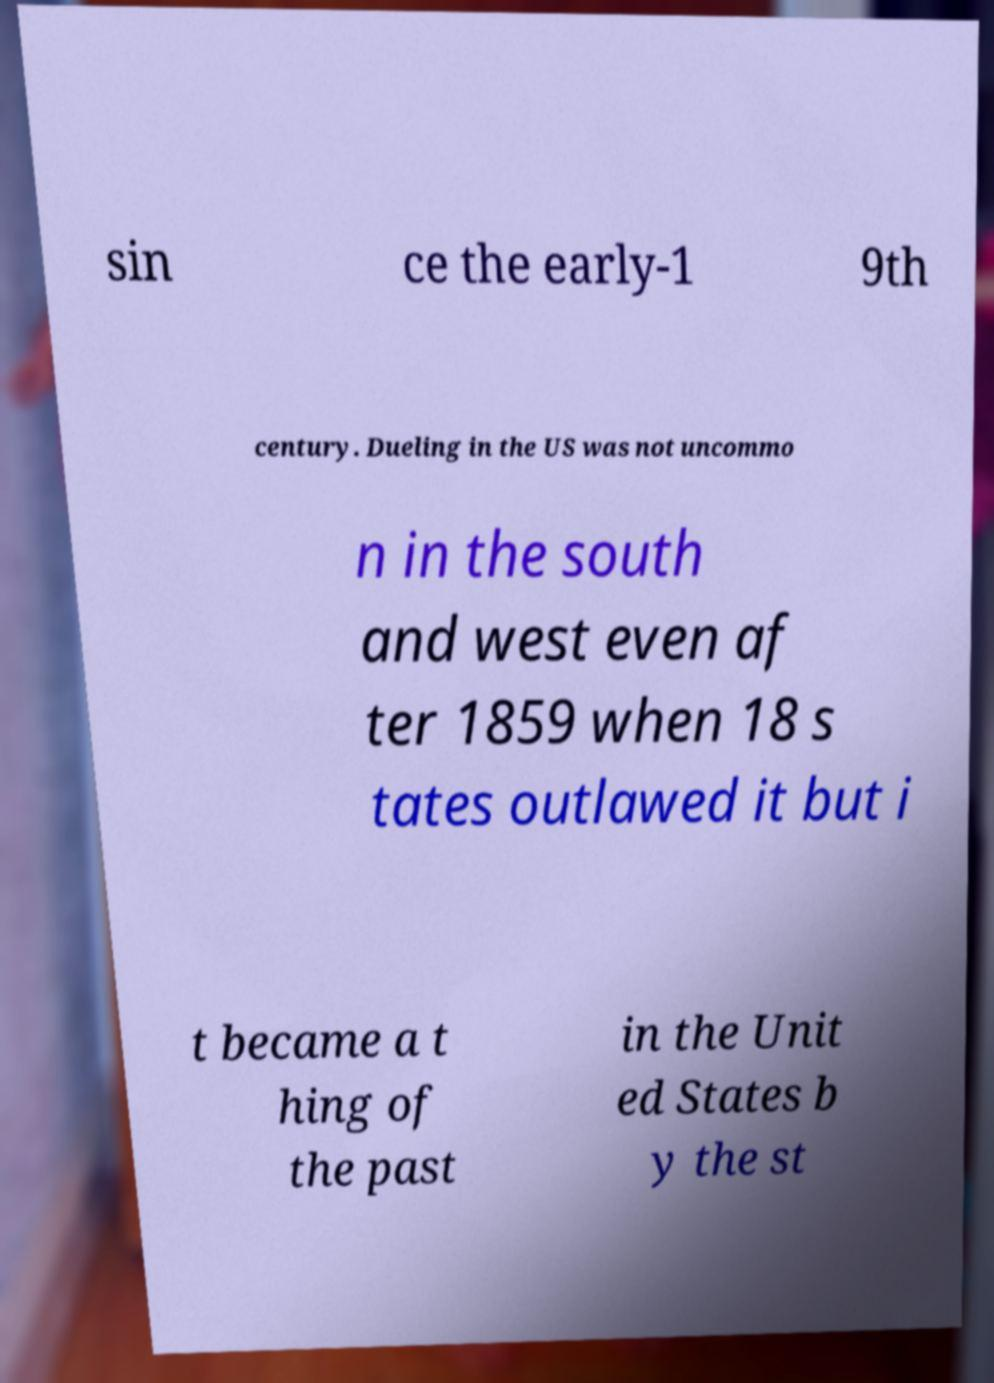Can you accurately transcribe the text from the provided image for me? sin ce the early-1 9th century. Dueling in the US was not uncommo n in the south and west even af ter 1859 when 18 s tates outlawed it but i t became a t hing of the past in the Unit ed States b y the st 